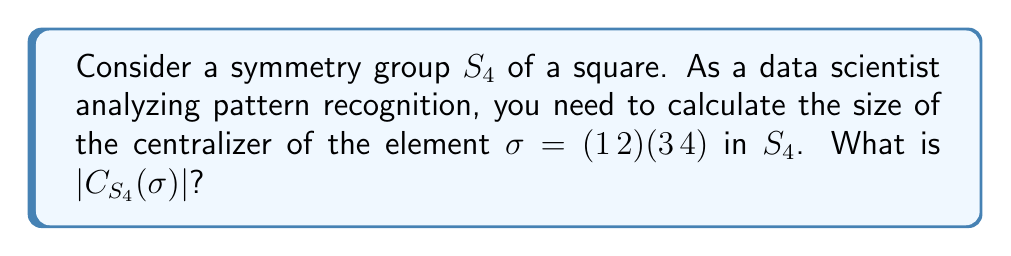Show me your answer to this math problem. To solve this problem, let's follow these steps:

1) First, recall that the centralizer of an element $\sigma$ in a group $G$ is defined as:
   $$C_G(\sigma) = \{g \in G : g\sigma = \sigma g\}$$

2) In $S_4$, we have 24 total elements. We need to count how many of these commute with $\sigma = (1\,2)(3\,4)$.

3) Let's consider the possible types of elements in $S_4$ that could commute with $\sigma$:

   a) The identity element always commutes with every element.
   
   b) $\sigma$ itself and $\sigma^3 = \sigma$ (since $\sigma^2 = e$) commute with $\sigma$.
   
   c) The element $(1\,3)(2\,4)$ commutes with $\sigma$ because it swaps the cycles of $\sigma$.
   
   d) The element $(1\,4)(2\,3)$ also commutes with $\sigma$ for the same reason.

4) Any other permutation that moves 1 to 3 or 2 to 4 won't commute with $\sigma$.

5) Therefore, the elements that commute with $\sigma$ are:
   $e, (1\,2)(3\,4), (1\,3)(2\,4), (1\,4)(2\,3)$

6) Counting these elements, we find that $|C_{S_4}(\sigma)| = 4$.

This result is particularly relevant for pattern recognition in data science, as it helps identify symmetries and invariances in data structures, which can be crucial for developing efficient algorithms and understanding underlying patterns in datasets.
Answer: $|C_{S_4}(\sigma)| = 4$ 